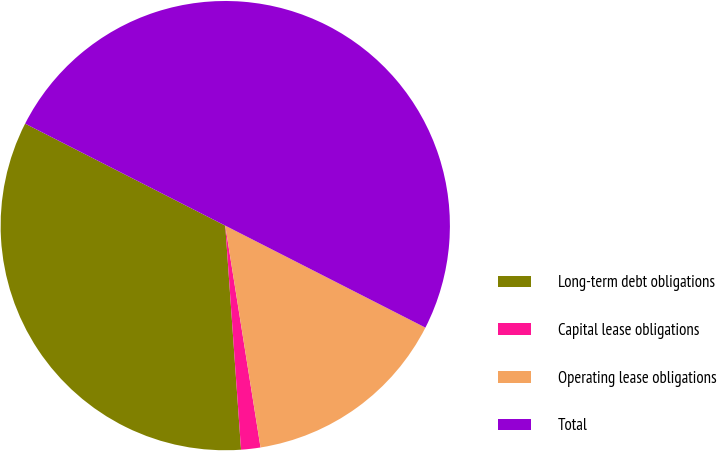Convert chart to OTSL. <chart><loc_0><loc_0><loc_500><loc_500><pie_chart><fcel>Long-term debt obligations<fcel>Capital lease obligations<fcel>Operating lease obligations<fcel>Total<nl><fcel>33.62%<fcel>1.39%<fcel>14.99%<fcel>50.0%<nl></chart> 